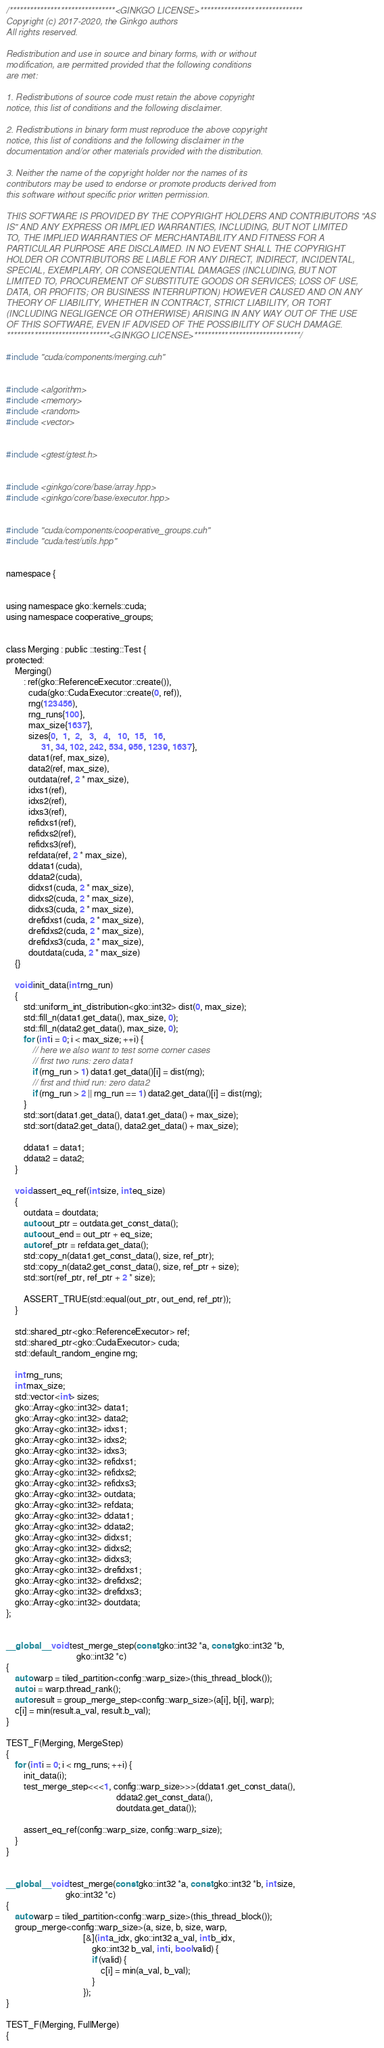Convert code to text. <code><loc_0><loc_0><loc_500><loc_500><_Cuda_>/*******************************<GINKGO LICENSE>******************************
Copyright (c) 2017-2020, the Ginkgo authors
All rights reserved.

Redistribution and use in source and binary forms, with or without
modification, are permitted provided that the following conditions
are met:

1. Redistributions of source code must retain the above copyright
notice, this list of conditions and the following disclaimer.

2. Redistributions in binary form must reproduce the above copyright
notice, this list of conditions and the following disclaimer in the
documentation and/or other materials provided with the distribution.

3. Neither the name of the copyright holder nor the names of its
contributors may be used to endorse or promote products derived from
this software without specific prior written permission.

THIS SOFTWARE IS PROVIDED BY THE COPYRIGHT HOLDERS AND CONTRIBUTORS "AS
IS" AND ANY EXPRESS OR IMPLIED WARRANTIES, INCLUDING, BUT NOT LIMITED
TO, THE IMPLIED WARRANTIES OF MERCHANTABILITY AND FITNESS FOR A
PARTICULAR PURPOSE ARE DISCLAIMED. IN NO EVENT SHALL THE COPYRIGHT
HOLDER OR CONTRIBUTORS BE LIABLE FOR ANY DIRECT, INDIRECT, INCIDENTAL,
SPECIAL, EXEMPLARY, OR CONSEQUENTIAL DAMAGES (INCLUDING, BUT NOT
LIMITED TO, PROCUREMENT OF SUBSTITUTE GOODS OR SERVICES; LOSS OF USE,
DATA, OR PROFITS; OR BUSINESS INTERRUPTION) HOWEVER CAUSED AND ON ANY
THEORY OF LIABILITY, WHETHER IN CONTRACT, STRICT LIABILITY, OR TORT
(INCLUDING NEGLIGENCE OR OTHERWISE) ARISING IN ANY WAY OUT OF THE USE
OF THIS SOFTWARE, EVEN IF ADVISED OF THE POSSIBILITY OF SUCH DAMAGE.
******************************<GINKGO LICENSE>*******************************/

#include "cuda/components/merging.cuh"


#include <algorithm>
#include <memory>
#include <random>
#include <vector>


#include <gtest/gtest.h>


#include <ginkgo/core/base/array.hpp>
#include <ginkgo/core/base/executor.hpp>


#include "cuda/components/cooperative_groups.cuh"
#include "cuda/test/utils.hpp"


namespace {


using namespace gko::kernels::cuda;
using namespace cooperative_groups;


class Merging : public ::testing::Test {
protected:
    Merging()
        : ref(gko::ReferenceExecutor::create()),
          cuda(gko::CudaExecutor::create(0, ref)),
          rng(123456),
          rng_runs{100},
          max_size{1637},
          sizes{0,  1,  2,   3,   4,   10,  15,   16,
                31, 34, 102, 242, 534, 956, 1239, 1637},
          data1(ref, max_size),
          data2(ref, max_size),
          outdata(ref, 2 * max_size),
          idxs1(ref),
          idxs2(ref),
          idxs3(ref),
          refidxs1(ref),
          refidxs2(ref),
          refidxs3(ref),
          refdata(ref, 2 * max_size),
          ddata1(cuda),
          ddata2(cuda),
          didxs1(cuda, 2 * max_size),
          didxs2(cuda, 2 * max_size),
          didxs3(cuda, 2 * max_size),
          drefidxs1(cuda, 2 * max_size),
          drefidxs2(cuda, 2 * max_size),
          drefidxs3(cuda, 2 * max_size),
          doutdata(cuda, 2 * max_size)
    {}

    void init_data(int rng_run)
    {
        std::uniform_int_distribution<gko::int32> dist(0, max_size);
        std::fill_n(data1.get_data(), max_size, 0);
        std::fill_n(data2.get_data(), max_size, 0);
        for (int i = 0; i < max_size; ++i) {
            // here we also want to test some corner cases
            // first two runs: zero data1
            if (rng_run > 1) data1.get_data()[i] = dist(rng);
            // first and third run: zero data2
            if (rng_run > 2 || rng_run == 1) data2.get_data()[i] = dist(rng);
        }
        std::sort(data1.get_data(), data1.get_data() + max_size);
        std::sort(data2.get_data(), data2.get_data() + max_size);

        ddata1 = data1;
        ddata2 = data2;
    }

    void assert_eq_ref(int size, int eq_size)
    {
        outdata = doutdata;
        auto out_ptr = outdata.get_const_data();
        auto out_end = out_ptr + eq_size;
        auto ref_ptr = refdata.get_data();
        std::copy_n(data1.get_const_data(), size, ref_ptr);
        std::copy_n(data2.get_const_data(), size, ref_ptr + size);
        std::sort(ref_ptr, ref_ptr + 2 * size);

        ASSERT_TRUE(std::equal(out_ptr, out_end, ref_ptr));
    }

    std::shared_ptr<gko::ReferenceExecutor> ref;
    std::shared_ptr<gko::CudaExecutor> cuda;
    std::default_random_engine rng;

    int rng_runs;
    int max_size;
    std::vector<int> sizes;
    gko::Array<gko::int32> data1;
    gko::Array<gko::int32> data2;
    gko::Array<gko::int32> idxs1;
    gko::Array<gko::int32> idxs2;
    gko::Array<gko::int32> idxs3;
    gko::Array<gko::int32> refidxs1;
    gko::Array<gko::int32> refidxs2;
    gko::Array<gko::int32> refidxs3;
    gko::Array<gko::int32> outdata;
    gko::Array<gko::int32> refdata;
    gko::Array<gko::int32> ddata1;
    gko::Array<gko::int32> ddata2;
    gko::Array<gko::int32> didxs1;
    gko::Array<gko::int32> didxs2;
    gko::Array<gko::int32> didxs3;
    gko::Array<gko::int32> drefidxs1;
    gko::Array<gko::int32> drefidxs2;
    gko::Array<gko::int32> drefidxs3;
    gko::Array<gko::int32> doutdata;
};


__global__ void test_merge_step(const gko::int32 *a, const gko::int32 *b,
                                gko::int32 *c)
{
    auto warp = tiled_partition<config::warp_size>(this_thread_block());
    auto i = warp.thread_rank();
    auto result = group_merge_step<config::warp_size>(a[i], b[i], warp);
    c[i] = min(result.a_val, result.b_val);
}

TEST_F(Merging, MergeStep)
{
    for (int i = 0; i < rng_runs; ++i) {
        init_data(i);
        test_merge_step<<<1, config::warp_size>>>(ddata1.get_const_data(),
                                                  ddata2.get_const_data(),
                                                  doutdata.get_data());

        assert_eq_ref(config::warp_size, config::warp_size);
    }
}


__global__ void test_merge(const gko::int32 *a, const gko::int32 *b, int size,
                           gko::int32 *c)
{
    auto warp = tiled_partition<config::warp_size>(this_thread_block());
    group_merge<config::warp_size>(a, size, b, size, warp,
                                   [&](int a_idx, gko::int32 a_val, int b_idx,
                                       gko::int32 b_val, int i, bool valid) {
                                       if (valid) {
                                           c[i] = min(a_val, b_val);
                                       }
                                   });
}

TEST_F(Merging, FullMerge)
{</code> 